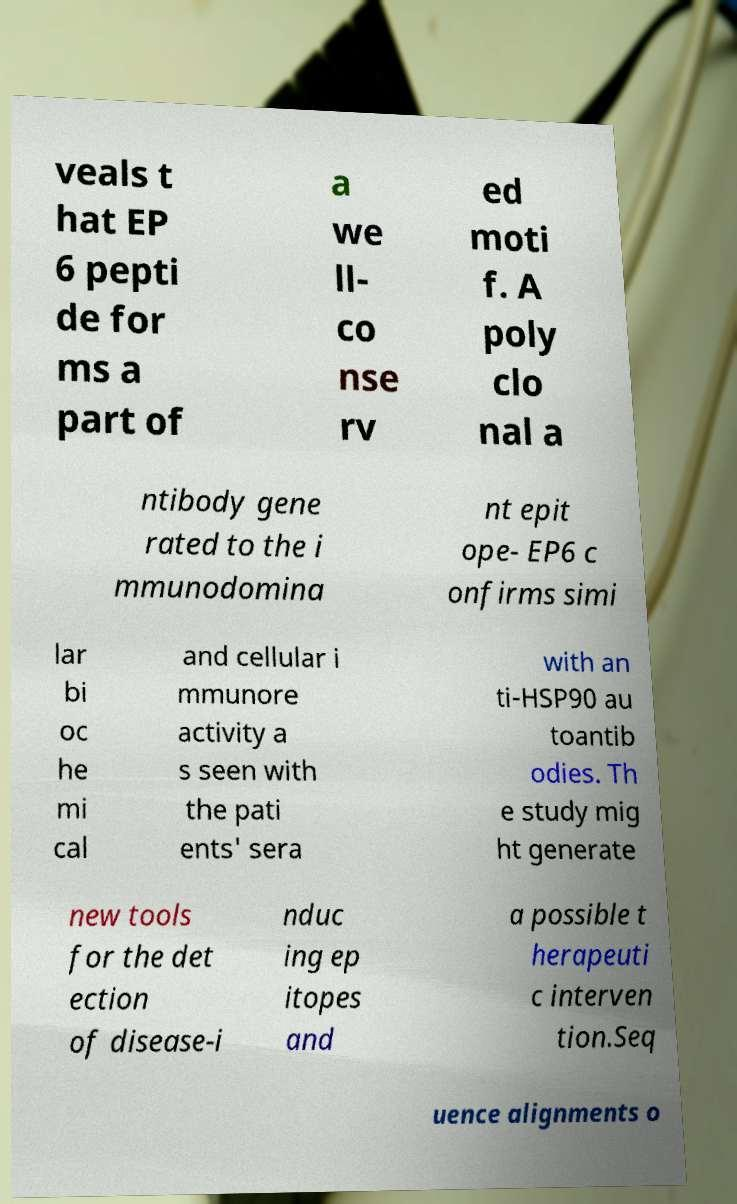Please identify and transcribe the text found in this image. veals t hat EP 6 pepti de for ms a part of a we ll- co nse rv ed moti f. A poly clo nal a ntibody gene rated to the i mmunodomina nt epit ope- EP6 c onfirms simi lar bi oc he mi cal and cellular i mmunore activity a s seen with the pati ents' sera with an ti-HSP90 au toantib odies. Th e study mig ht generate new tools for the det ection of disease-i nduc ing ep itopes and a possible t herapeuti c interven tion.Seq uence alignments o 